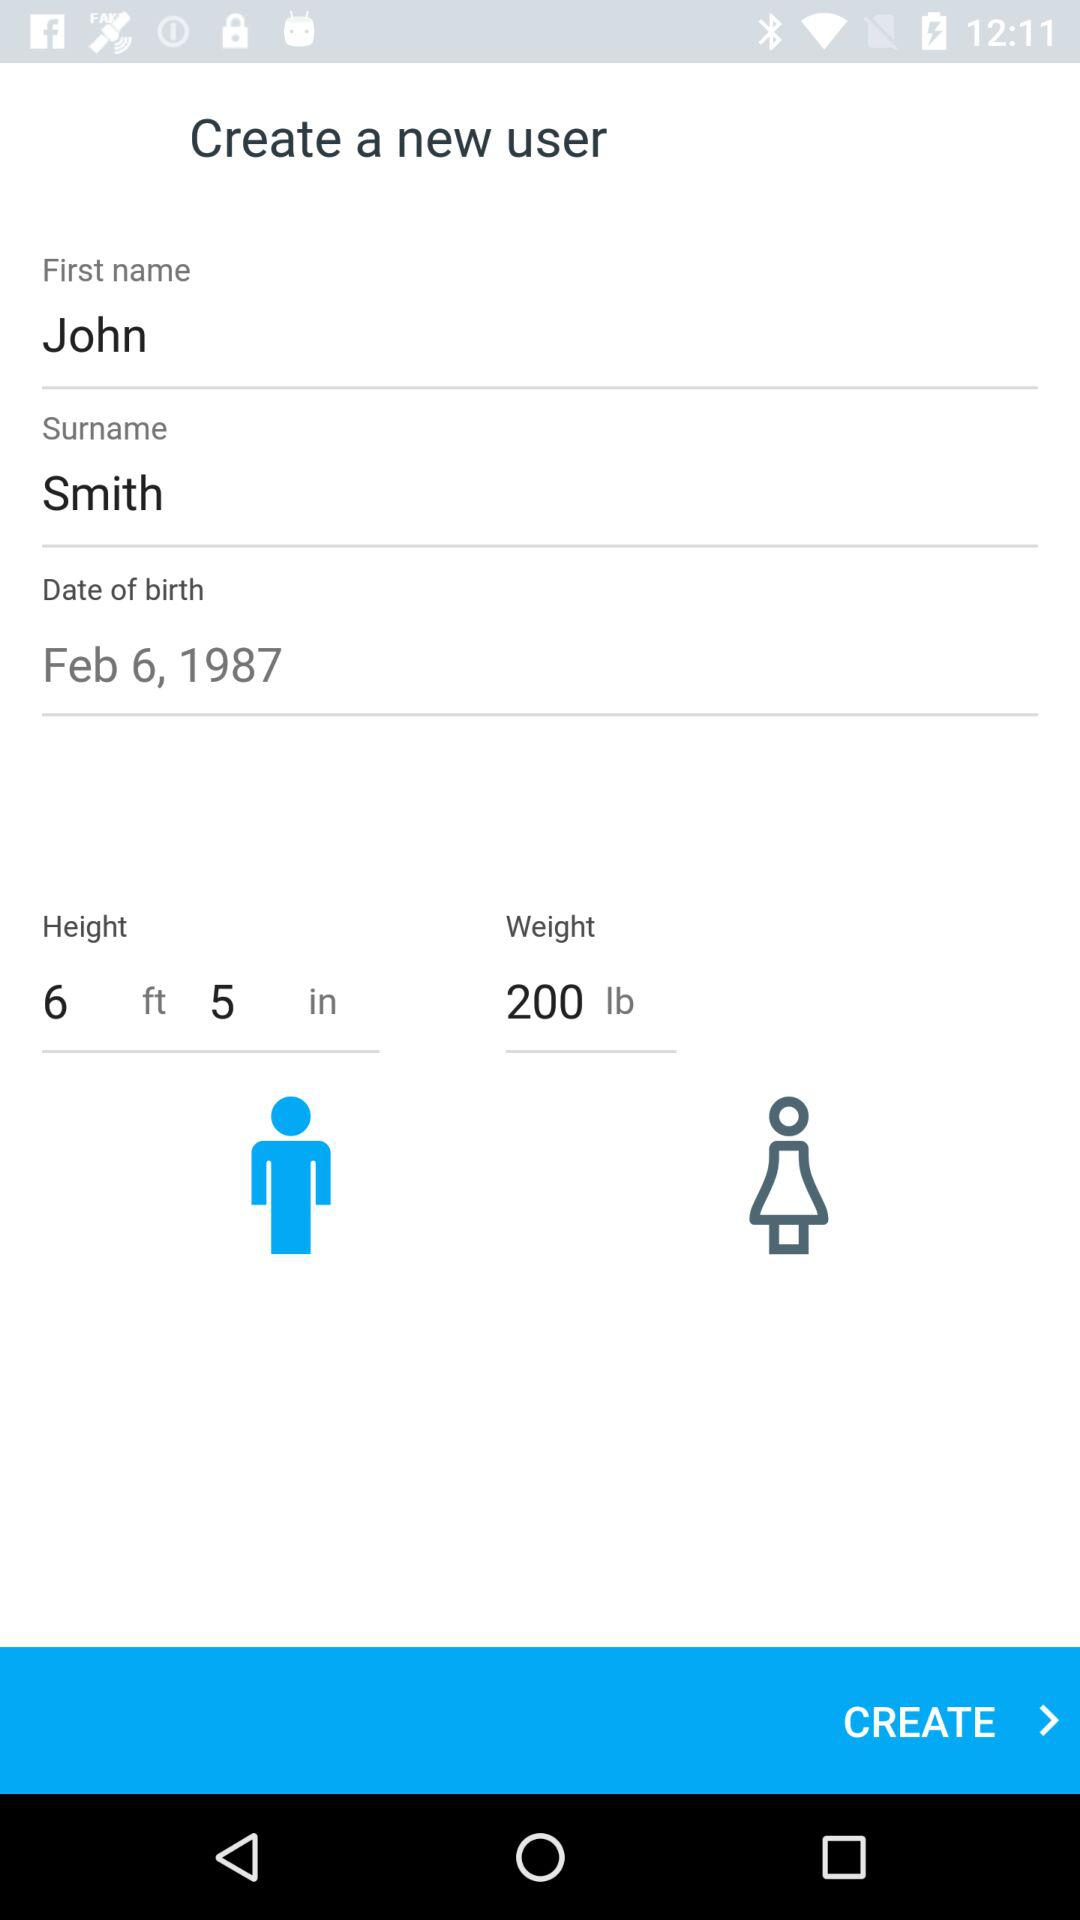What is the first name? The first name is John. 